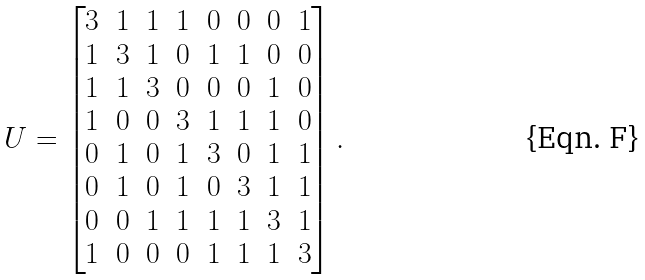<formula> <loc_0><loc_0><loc_500><loc_500>U = \begin{bmatrix} 3 & 1 & 1 & 1 & 0 & 0 & 0 & 1 \\ 1 & 3 & 1 & 0 & 1 & 1 & 0 & 0 \\ 1 & 1 & 3 & 0 & 0 & 0 & 1 & 0 \\ 1 & 0 & 0 & 3 & 1 & 1 & 1 & 0 \\ 0 & 1 & 0 & 1 & 3 & 0 & 1 & 1 \\ 0 & 1 & 0 & 1 & 0 & 3 & 1 & 1 \\ 0 & 0 & 1 & 1 & 1 & 1 & 3 & 1 \\ 1 & 0 & 0 & 0 & 1 & 1 & 1 & 3 \end{bmatrix} .</formula> 